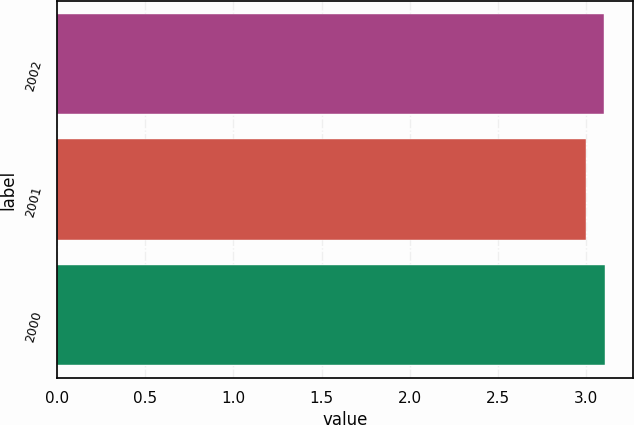Convert chart. <chart><loc_0><loc_0><loc_500><loc_500><bar_chart><fcel>2002<fcel>2001<fcel>2000<nl><fcel>3.1<fcel>3<fcel>3.11<nl></chart> 